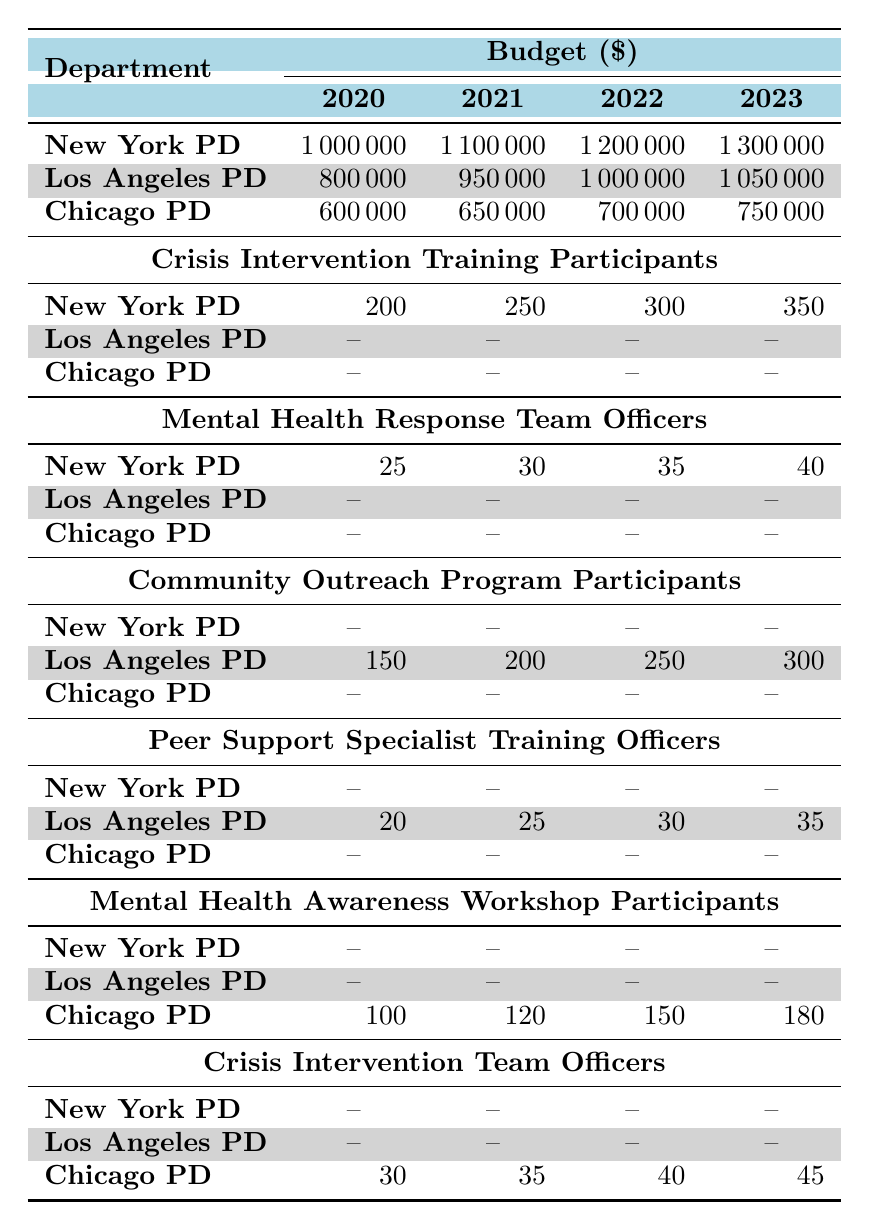What was the budget of the New York Police Department in 2022? The budget for the New York Police Department in 2022 is specified in the table as 1,200,000.
Answer: 1,200,000 How many officers were part of the Mental Health Response Teams in the Chicago Police Department in 2021? The table indicates that the Chicago Police Department had 35 officers in the Mental Health Response Teams in 2021.
Answer: 35 What is the total number of participants in the Community Outreach Programs for Los Angeles Police Department from 2020 to 2023? The participants from Los Angeles Police Department in Community Outreach Programs are: 150 (2020) + 200 (2021) + 250 (2022) + 300 (2023) = 900.
Answer: 900 Did the budget for the Chicago Police Department increase every year from 2020 to 2023? According to the table, the budget for the Chicago Police Department increased each year: 600,000 (2020) to 650,000 (2021) to 700,000 (2022) to 750,000 (2023), indicating a consistent increase.
Answer: Yes What is the average number of participants in Mental Health Awareness Workshops for the Chicago Police Department from 2020 to 2023? The number of participants in Mental Health Awareness Workshops for Chicago Police Department are: 100 (2020), 120 (2021), 150 (2022), and 180 (2023). The average is calculated as (100 + 120 + 150 + 180) / 4 = 137.5.
Answer: 137.5 How many more participants were there in the Crisis Intervention Training for New York Police Department in 2023 compared to 2020? The number of participants in Crisis Intervention Training for New York Police Department was 200 in 2020 and 350 in 2023. The difference is 350 - 200 = 150.
Answer: 150 What was the funding for the peer support specialist training in Los Angeles Police Department in 2022? The table shows that the funding allocated for the Peer Support Specialist Training in Los Angeles Police Department in 2022 was 600,000.
Answer: 600,000 Is it true that the number of officers in the Crisis Intervention Teams for Chicago Police Department increased every year? The table indicates numbers for officers in Crisis Intervention Teams for Chicago Police Department as: 30 (2020), 35 (2021), 40 (2022), and 45 (2023), confirming an increase each year.
Answer: Yes How much funding did the New York Police Department allocate for its Mental Health Response Teams in 2021? The funding for Mental Health Response Teams by New York Police Department in 2021 is specified in the table as 800,000.
Answer: 800,000 What was the percentage increase in the budget of the Los Angeles Police Department from 2020 to 2023? The budget for Los Angeles Police Department in 2020 was 800,000 and in 2023 was 1,050,000. The increase is (1,050,000 - 800,000) / 800,000 * 100 = 31.25%.
Answer: 31.25% 